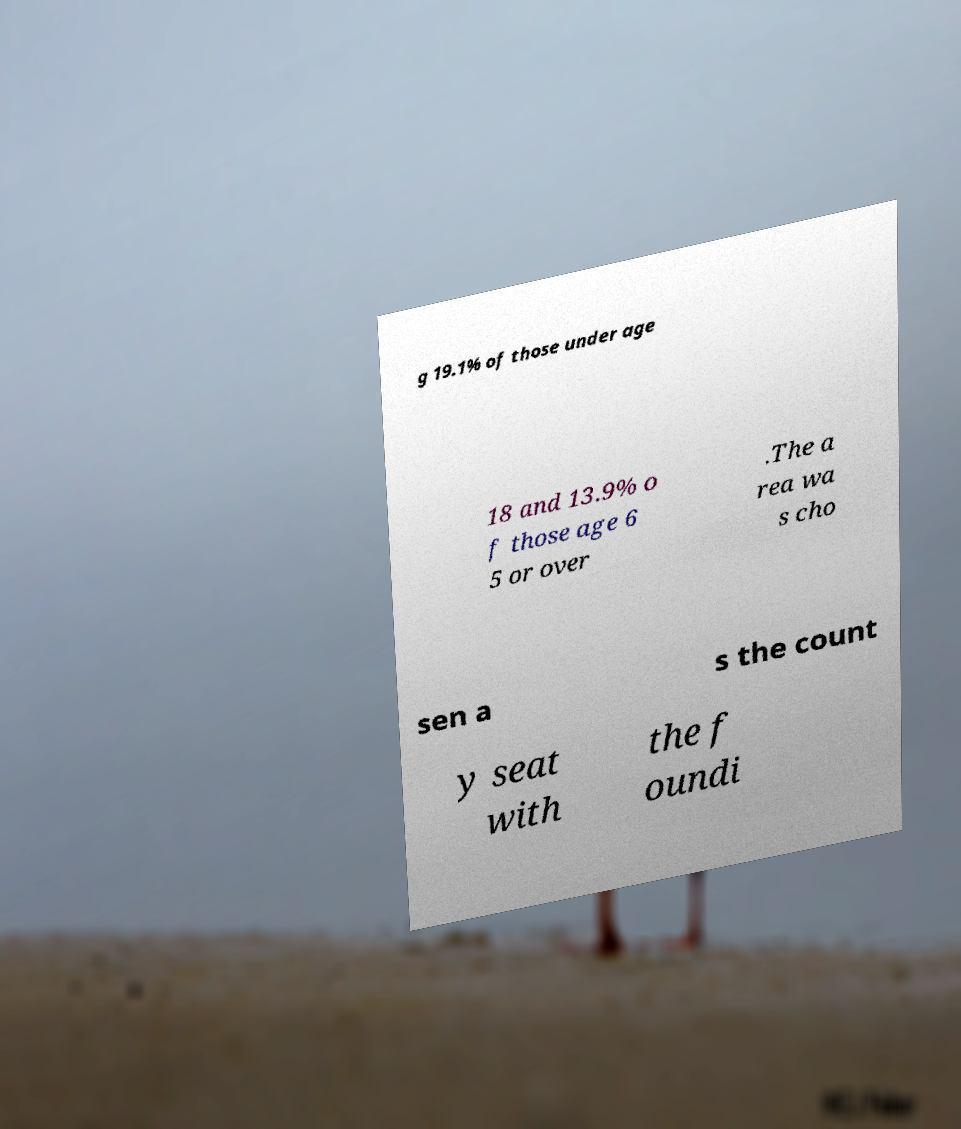Please identify and transcribe the text found in this image. g 19.1% of those under age 18 and 13.9% o f those age 6 5 or over .The a rea wa s cho sen a s the count y seat with the f oundi 